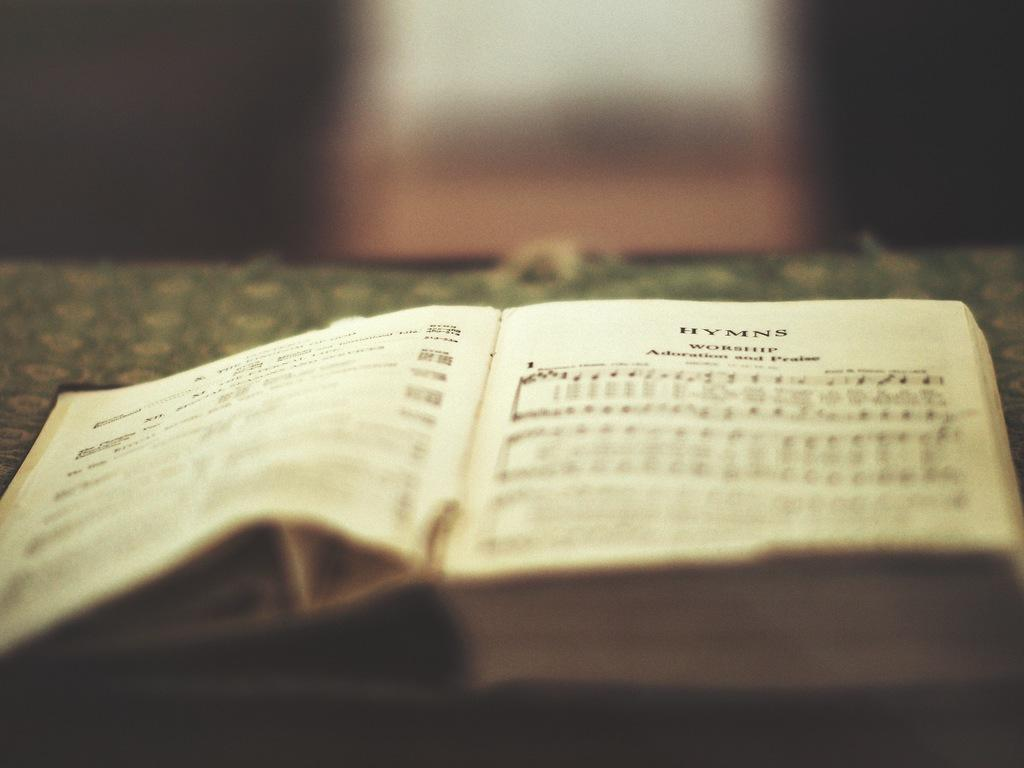Provide a one-sentence caption for the provided image. open music book sits on the table music hymns. 